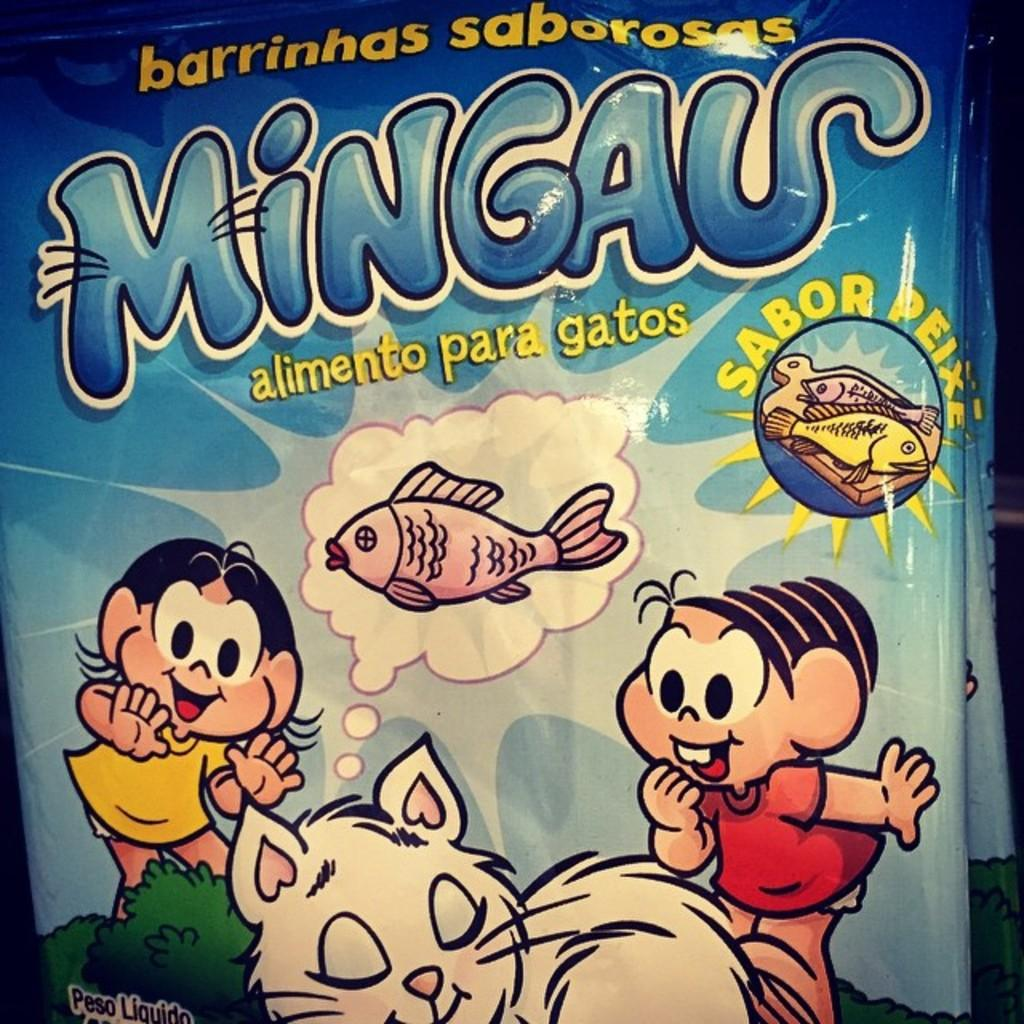What color is the main object in the image? There is a blue object in the image. What type of images are depicted on the blue object? Cartoons, fishes, and a cat are depicted on the blue object. Are there any words written on the blue object? Yes, there is text written on the blue object. What sense does the cat use to solve the riddle depicted on the blue object? There is no riddle depicted on the blue object, and therefore no sense is used by the cat to solve it. 